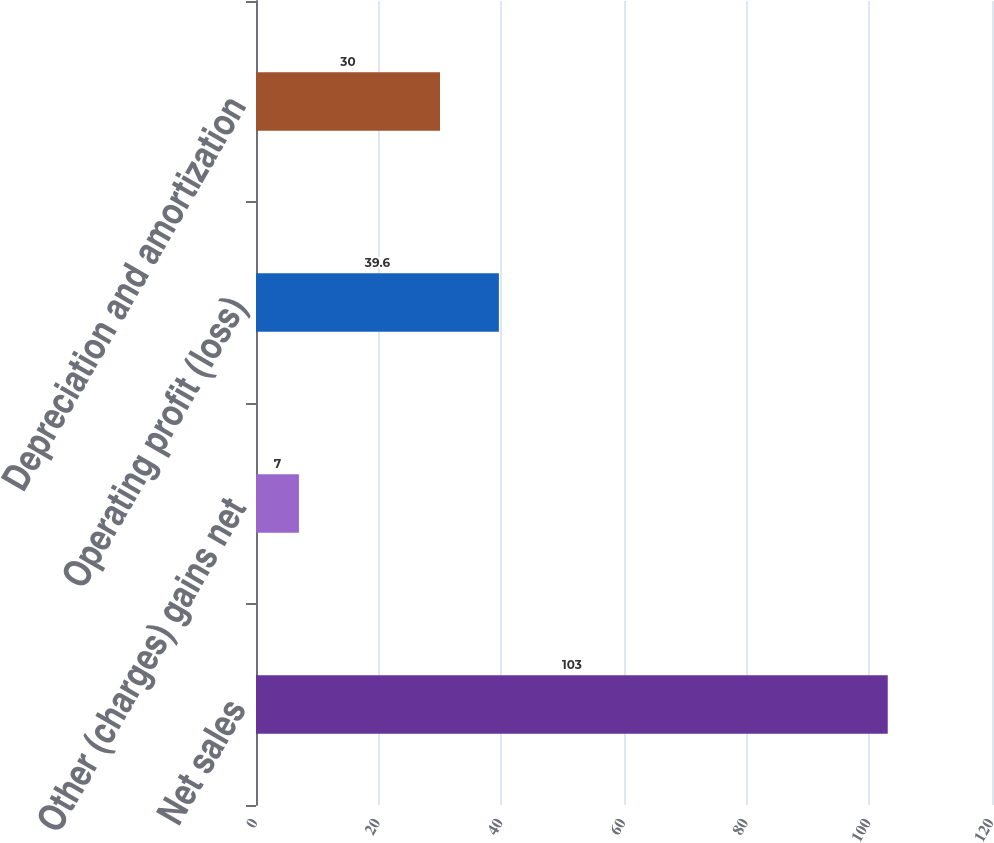Convert chart. <chart><loc_0><loc_0><loc_500><loc_500><bar_chart><fcel>Net sales<fcel>Other (charges) gains net<fcel>Operating profit (loss)<fcel>Depreciation and amortization<nl><fcel>103<fcel>7<fcel>39.6<fcel>30<nl></chart> 